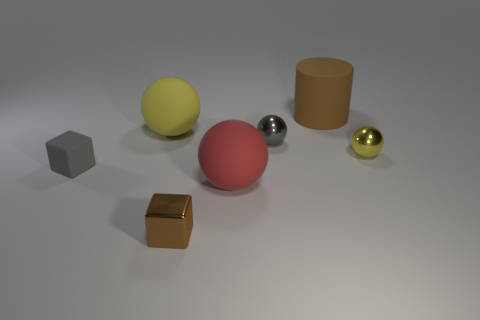There is another metallic cube that is the same size as the gray block; what color is it?
Keep it short and to the point. Brown. Is the number of matte spheres that are to the right of the big matte cylinder less than the number of gray cubes that are in front of the tiny brown metal cube?
Keep it short and to the point. No. There is a rubber ball that is on the left side of the red matte sphere; is it the same size as the small yellow metallic thing?
Keep it short and to the point. No. There is a small gray object that is on the right side of the gray matte object; what shape is it?
Keep it short and to the point. Sphere. Is the number of gray balls greater than the number of big cyan spheres?
Your answer should be compact. Yes. Is the color of the large ball that is behind the gray rubber thing the same as the matte cylinder?
Provide a short and direct response. No. What number of objects are either yellow objects right of the large yellow matte sphere or objects that are right of the matte block?
Keep it short and to the point. 6. How many things are both right of the gray matte block and behind the tiny brown shiny cube?
Your answer should be compact. 5. Is the material of the big red object the same as the large brown object?
Provide a succinct answer. Yes. What shape is the red matte thing that is in front of the cube that is behind the metal thing that is in front of the small gray rubber thing?
Your answer should be very brief. Sphere. 